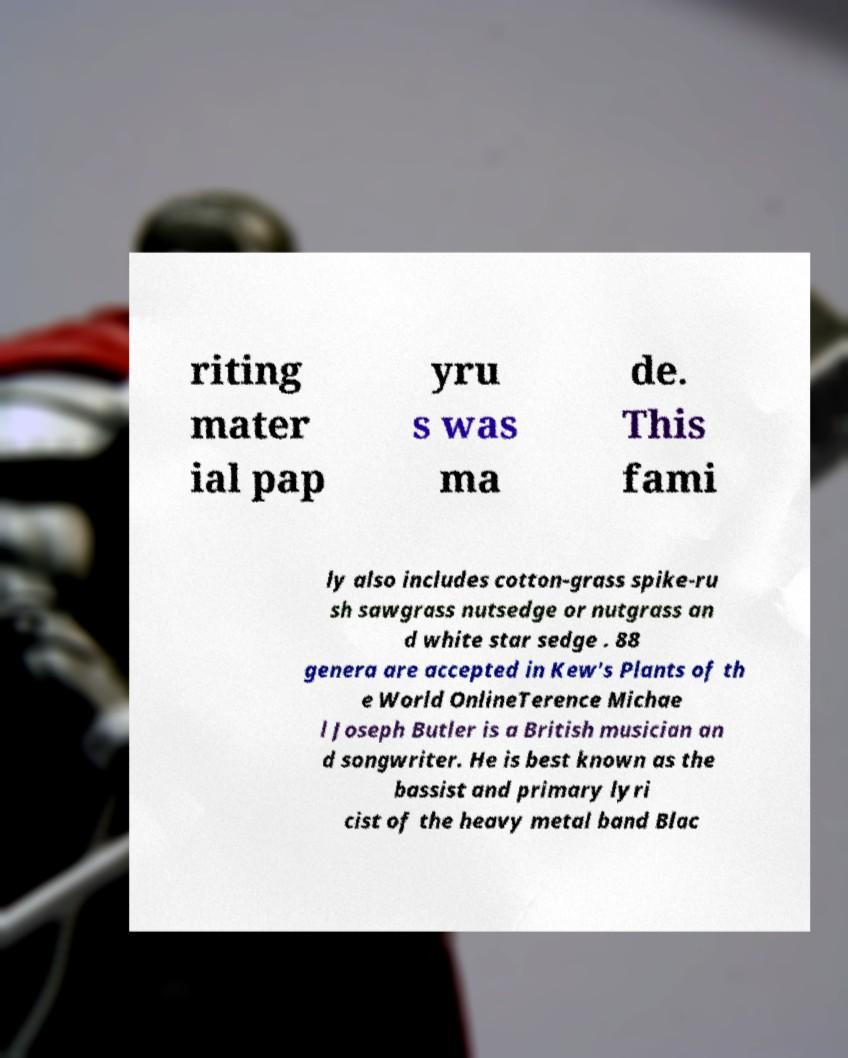Please read and relay the text visible in this image. What does it say? riting mater ial pap yru s was ma de. This fami ly also includes cotton-grass spike-ru sh sawgrass nutsedge or nutgrass an d white star sedge . 88 genera are accepted in Kew's Plants of th e World OnlineTerence Michae l Joseph Butler is a British musician an d songwriter. He is best known as the bassist and primary lyri cist of the heavy metal band Blac 